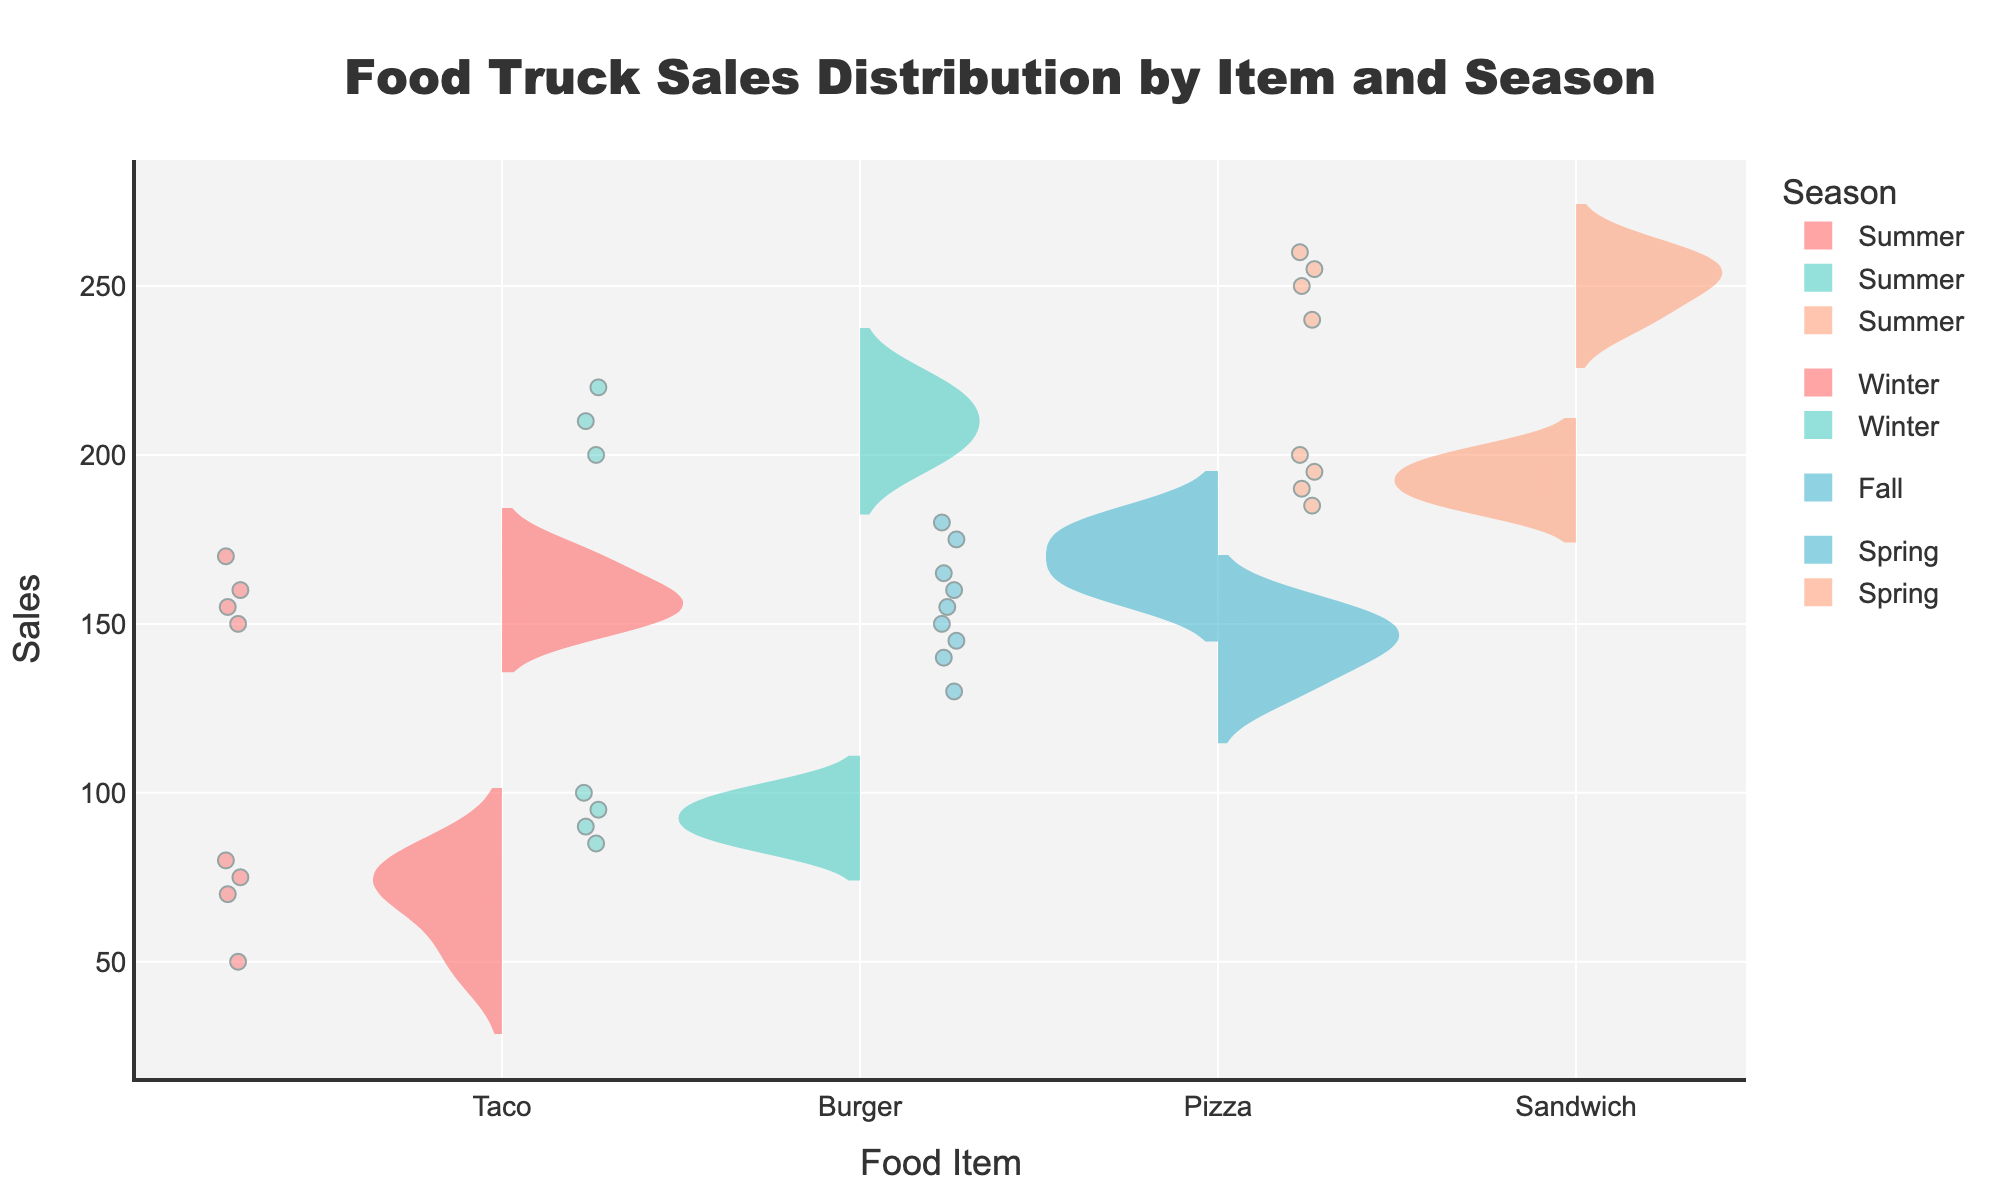What is the title of the figure? The title of the figure is located at the top center and usually provides a quick summary of what the figure represents.
Answer: Food Truck Sales Distribution by Item and Season Which food item has the largest sales distribution range in the summer? By looking at the length of the violins for each food item in the summer, we can compare their sales distribution ranges. The one with the largest range will have the longest violin.
Answer: Sandwich What season shows the lowest sales distribution for tacos? We need to check the violins for tacos in each season and identify the smallest sales distribution. Winter will have a narrow or shorter violin for tacos.
Answer: Winter Which food item has the most consistent sales distribution in any season? Consistent sales distribution can be inferred from the thinnest or most compact violin. We need to look for the most compact violin for any food item per season.
Answer: Pizza in Fall Are burger sales higher in summer or winter? Compare the location and spread of the violins for burgers in summer and winter. Higher sales will reflect in a violin positioned higher on the y-axis.
Answer: Summer What is the interquartile range (IQR) for sandwiches in spring? The IQR represents the middle 50% of the data, shown as the thick section in the center of the violin. Examine the sandwich's violin in spring and note the range from Q1 to Q3. If Q1 is 185 and Q3 is 195, the IQR is 195 - 185.
Answer: 10 Which season has the widest range in sales for any food item? Examine all violins and pick the one with the greatest length. Note the season associated with it.
Answer: Summer (Sandwich) How do the sales distributions of tacos compare between summer and winter? Compare the shapes, positions, and spreads of the violins for tacos in both summer and winter. Noting whether one is higher, wider, or differently shaped.
Answer: Higher and wider in summer compared to winter What is the median sales value for pizzas in spring? The median value is represented by the white line inside the box part of the violin for pizzas in spring. Observe this value directly from the figure. If the line is at 170, the median is 170.
Answer: 170 Do any food items show overlapping sales distributions in different seasons? Look for violins that appear to have overlapping areas on the chart, indicating that their sales distributions share values. Particularly where edges or areas of violins intersect.
Answer: No significant overlap 